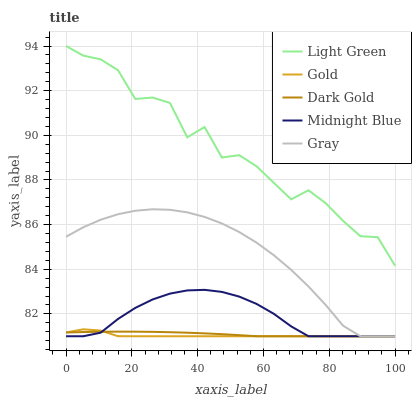Does Gold have the minimum area under the curve?
Answer yes or no. Yes. Does Midnight Blue have the minimum area under the curve?
Answer yes or no. No. Does Midnight Blue have the maximum area under the curve?
Answer yes or no. No. Is Light Green the roughest?
Answer yes or no. Yes. Is Midnight Blue the smoothest?
Answer yes or no. No. Is Midnight Blue the roughest?
Answer yes or no. No. Does Light Green have the lowest value?
Answer yes or no. No. Does Midnight Blue have the highest value?
Answer yes or no. No. Is Gold less than Light Green?
Answer yes or no. Yes. Is Light Green greater than Dark Gold?
Answer yes or no. Yes. Does Gold intersect Light Green?
Answer yes or no. No. 